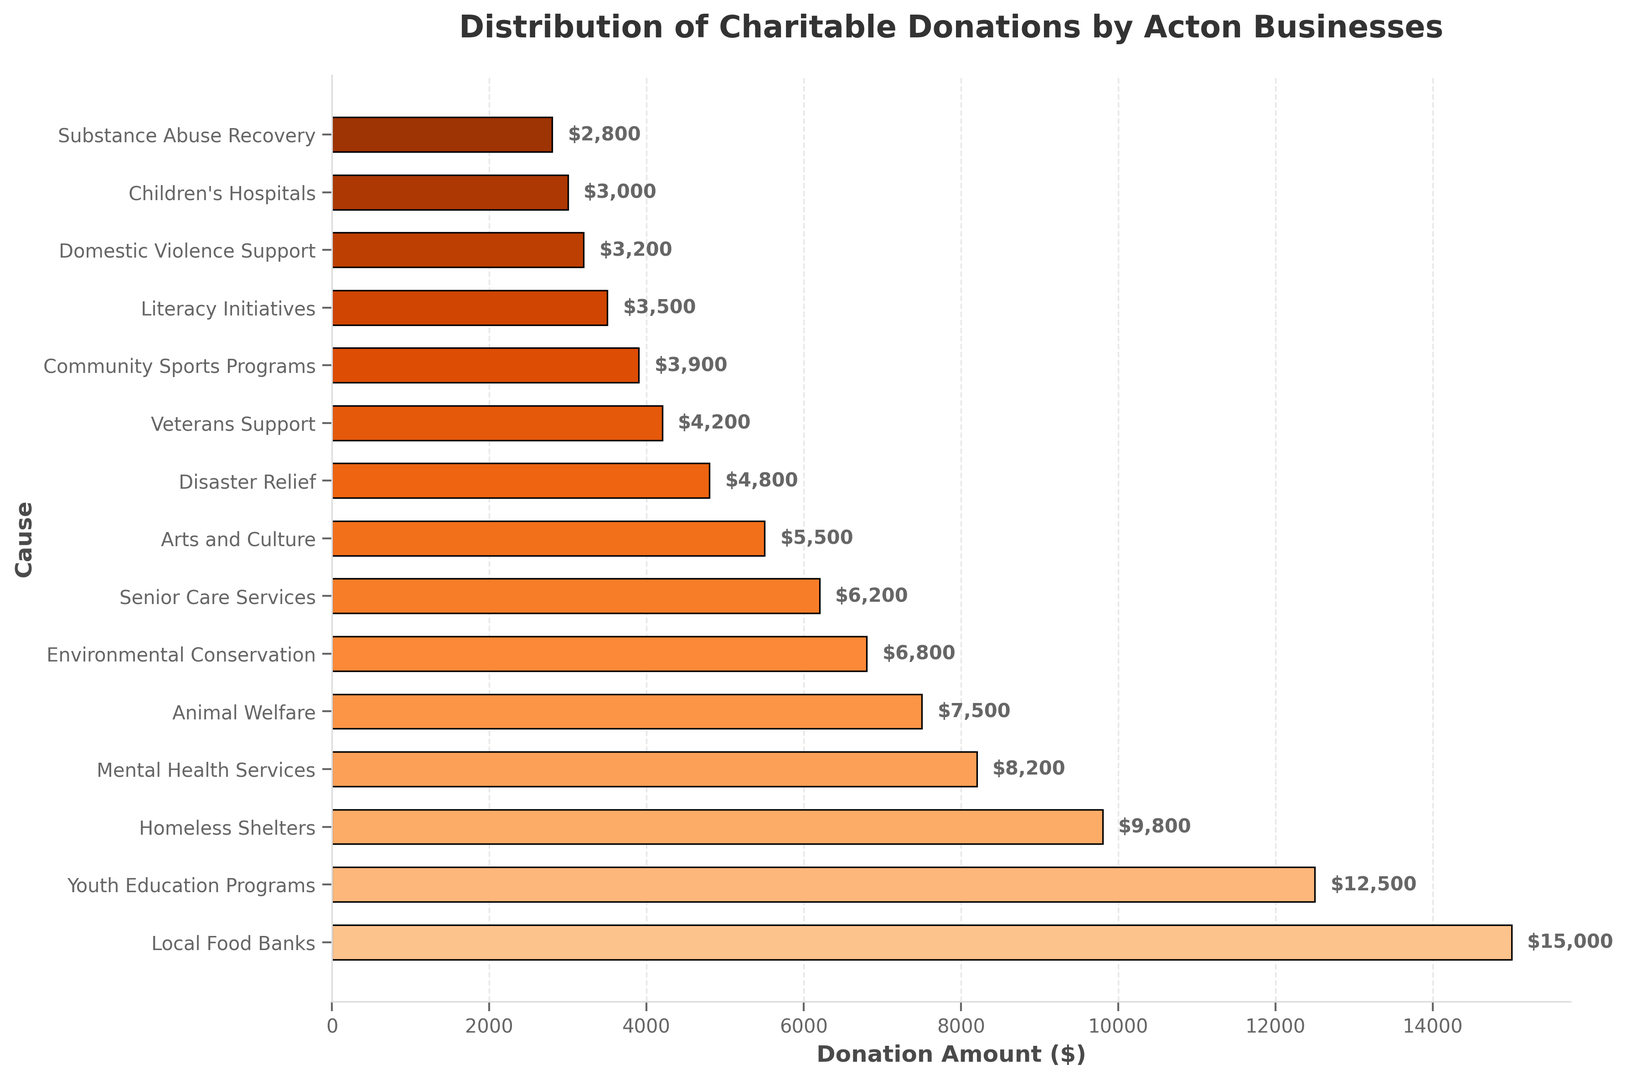Which cause received the largest donation amount? The figure shows horizontal bars representing donation amounts, where the longest bar corresponds to the cause with the largest donation. The bar for Local Food Banks is the longest.
Answer: Local Food Banks What is the difference between the donations to Youth Education Programs and Animal Welfare? Identify the donation amounts for both causes from the figure. Youth Education Programs received $12,500 and Animal Welfare received $7,500. Calculate the difference: $12,500 - $7,500.
Answer: $5,000 How many causes received donations of $5,000 or more? Count the bars in the figure that represent donation amounts of $5,000 or more. These are the ones with bars extending to at least the $5,000 mark on the x-axis.
Answer: 9 causes Which cause received the smallest donation amount? The figure shows horizontal bars representing donation amounts, where the shortest bar corresponds to the cause with the smallest donation. The bar for Substance Abuse Recovery is the shortest.
Answer: Substance Abuse Recovery Are the donations to Domestic Violence Support and Community Sports Programs equal? Compare the lengths of the bars representing these two causes. The bar for Domestic Violence Support is shorter than the bar for Community Sports Programs, indicating different amounts.
Answer: No What is the combined donation amount for Disaster Relief, Veterans Support, and Literacy Initiatives? Identify the donation amounts for these three causes from the figure: $4,800 for Disaster Relief, $4,200 for Veterans Support, and $3,500 for Literacy Initiatives. Sum these amounts: $4,800 + $4,200 + $3,500.
Answer: $12,500 How much more did Local Food Banks receive compared to Children's Hospitals? Identify the donation amounts for both causes from the figure. Local Food Banks received $15,000 and Children's Hospitals received $3,000. Calculate the difference: $15,000 - $3,000.
Answer: $12,000 What is the average donation amount across all causes? Sum the donation amounts for all causes and divide by the number of causes. Sum: $15,000 + $12,500 + $9,800 + $8,200 + $7,500 + $6,800 + $6,200 + $5,500 + $4,800 + $4,200 + $3,900 + $3,500 + $3,200 + $3,000 + $2,800 = $96,900. Number of causes: 15. Average: $96,900 / 15.
Answer: $6,460 Which received more donations: Mental Health Services or Senior Care Services? Compare the lengths of the bars representing these two causes. The bar for Mental Health Services is longer than the bar for Senior Care Services.
Answer: Mental Health Services What is the total donation amount for all educational-related causes (Youth Education Programs, Literacy Initiatives)? Identify the donation amounts for these causes from the figure: $12,500 for Youth Education Programs and $3,500 for Literacy Initiatives. Sum these amounts: $12,500 + $3,500.
Answer: $16,000 